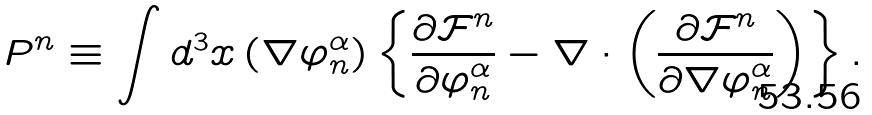Convert formula to latex. <formula><loc_0><loc_0><loc_500><loc_500>P ^ { n } \equiv \int d ^ { 3 } x \left ( \nabla \varphi _ { n } ^ { \alpha } \right ) \left \{ \frac { \partial \mathcal { F } ^ { n } } { \partial \varphi _ { n } ^ { \alpha } } - \nabla \cdot \left ( \frac { \partial \mathcal { F } ^ { n } } { \partial \nabla \varphi _ { n } ^ { \alpha } } \right ) \right \} .</formula> 